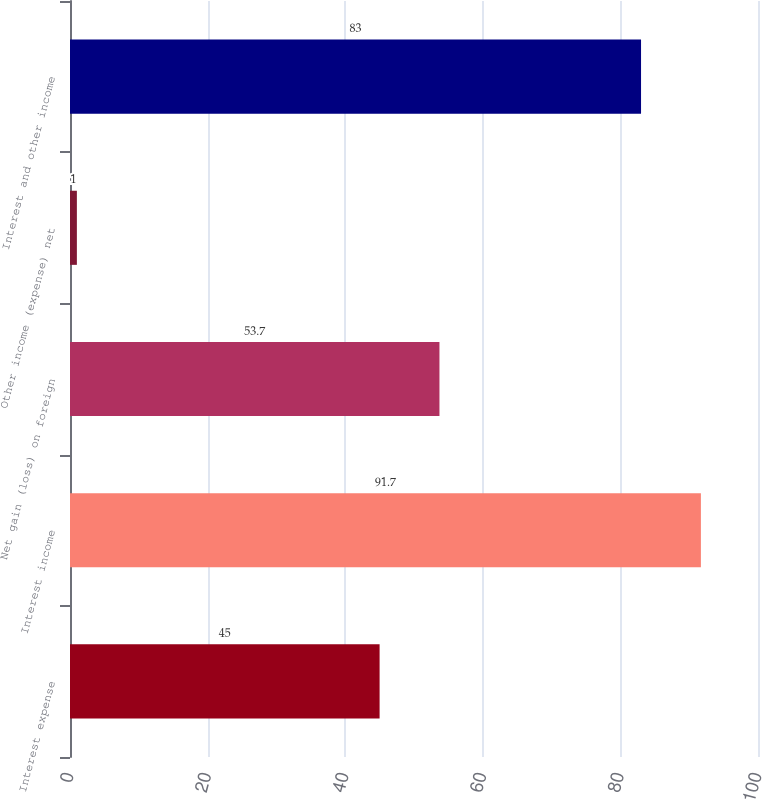<chart> <loc_0><loc_0><loc_500><loc_500><bar_chart><fcel>Interest expense<fcel>Interest income<fcel>Net gain (loss) on foreign<fcel>Other income (expense) net<fcel>Interest and other income<nl><fcel>45<fcel>91.7<fcel>53.7<fcel>1<fcel>83<nl></chart> 